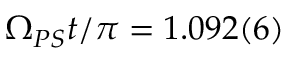<formula> <loc_0><loc_0><loc_500><loc_500>\Omega _ { P S } t / \pi = 1 . 0 9 2 ( 6 )</formula> 